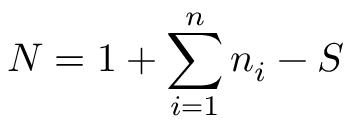<formula> <loc_0><loc_0><loc_500><loc_500>N = 1 + \sum _ { i = 1 } ^ { n } n _ { i } - S</formula> 